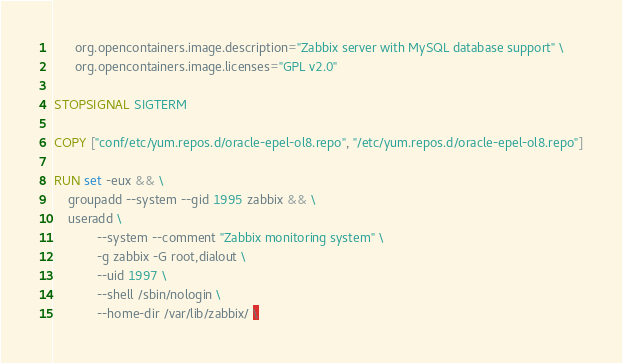<code> <loc_0><loc_0><loc_500><loc_500><_Dockerfile_>      org.opencontainers.image.description="Zabbix server with MySQL database support" \
      org.opencontainers.image.licenses="GPL v2.0"

STOPSIGNAL SIGTERM

COPY ["conf/etc/yum.repos.d/oracle-epel-ol8.repo", "/etc/yum.repos.d/oracle-epel-ol8.repo"]

RUN set -eux && \
    groupadd --system --gid 1995 zabbix && \
    useradd \
            --system --comment "Zabbix monitoring system" \
            -g zabbix -G root,dialout \
            --uid 1997 \
            --shell /sbin/nologin \
            --home-dir /var/lib/zabbix/ \</code> 